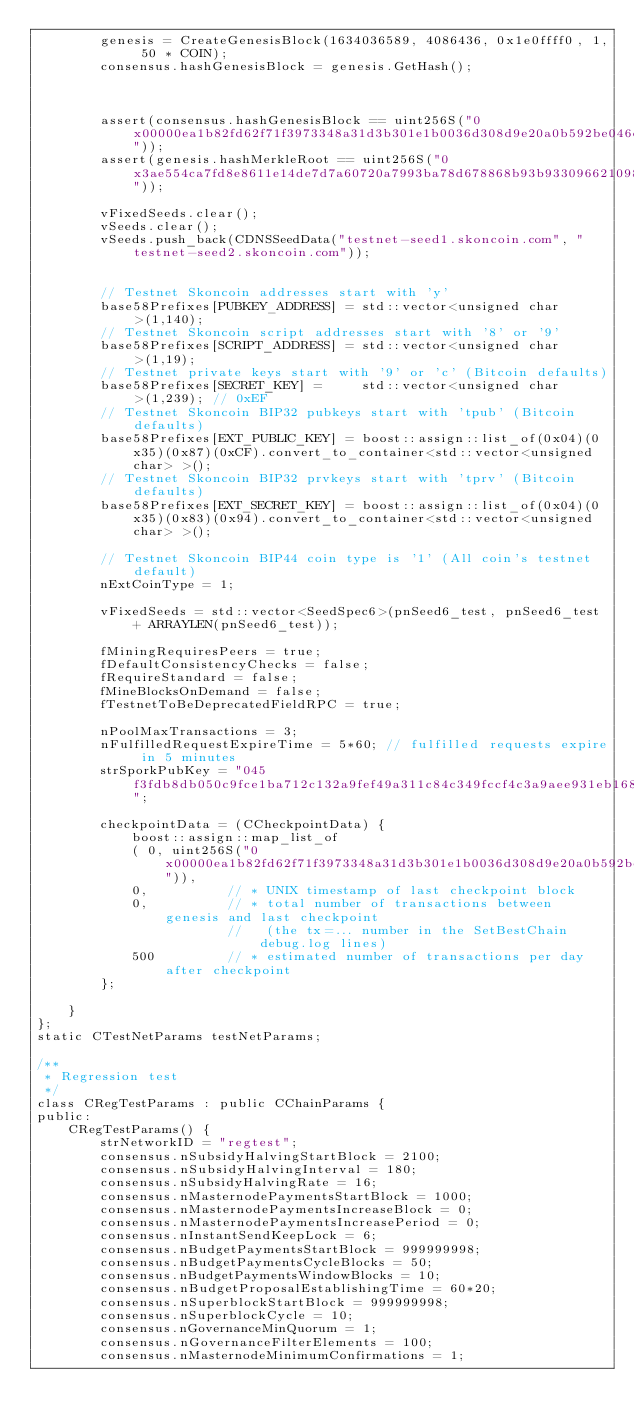<code> <loc_0><loc_0><loc_500><loc_500><_C++_>        genesis = CreateGenesisBlock(1634036589, 4086436, 0x1e0ffff0, 1, 50 * COIN);
        consensus.hashGenesisBlock = genesis.GetHash();

       

        assert(consensus.hashGenesisBlock == uint256S("0x00000ea1b82fd62f71f3973348a31d3b301e1b0036d308d9e20a0b592be046eb"));
        assert(genesis.hashMerkleRoot == uint256S("0x3ae554ca7fd8e8611e14de7d7a60720a7993ba78d678868b93b933096621098b"));

        vFixedSeeds.clear();
        vSeeds.clear();
        vSeeds.push_back(CDNSSeedData("testnet-seed1.skoncoin.com", "testnet-seed2.skoncoin.com"));


        // Testnet Skoncoin addresses start with 'y'
        base58Prefixes[PUBKEY_ADDRESS] = std::vector<unsigned char>(1,140);
        // Testnet Skoncoin script addresses start with '8' or '9'
        base58Prefixes[SCRIPT_ADDRESS] = std::vector<unsigned char>(1,19);
        // Testnet private keys start with '9' or 'c' (Bitcoin defaults)
        base58Prefixes[SECRET_KEY] =     std::vector<unsigned char>(1,239); // 0xEF
        // Testnet Skoncoin BIP32 pubkeys start with 'tpub' (Bitcoin defaults)
        base58Prefixes[EXT_PUBLIC_KEY] = boost::assign::list_of(0x04)(0x35)(0x87)(0xCF).convert_to_container<std::vector<unsigned char> >();
        // Testnet Skoncoin BIP32 prvkeys start with 'tprv' (Bitcoin defaults)
        base58Prefixes[EXT_SECRET_KEY] = boost::assign::list_of(0x04)(0x35)(0x83)(0x94).convert_to_container<std::vector<unsigned char> >();

        // Testnet Skoncoin BIP44 coin type is '1' (All coin's testnet default)
        nExtCoinType = 1;

        vFixedSeeds = std::vector<SeedSpec6>(pnSeed6_test, pnSeed6_test + ARRAYLEN(pnSeed6_test));

        fMiningRequiresPeers = true;
        fDefaultConsistencyChecks = false;
        fRequireStandard = false;
        fMineBlocksOnDemand = false;
        fTestnetToBeDeprecatedFieldRPC = true;

        nPoolMaxTransactions = 3;
        nFulfilledRequestExpireTime = 5*60; // fulfilled requests expire in 5 minutes
        strSporkPubKey = "045f3fdb8db050c9fce1ba712c132a9fef49a311c84c349fccf4c3a9aee931eb168c216aa54f6614318334cbdb409497ad0f87f1fab7c9c5dcd32f8d0dbf1369f4";

        checkpointData = (CCheckpointData) {
            boost::assign::map_list_of
            ( 0, uint256S("0x00000ea1b82fd62f71f3973348a31d3b301e1b0036d308d9e20a0b592be046eb")),
            0,          // * UNIX timestamp of last checkpoint block
            0,          // * total number of transactions between genesis and last checkpoint
                        //   (the tx=... number in the SetBestChain debug.log lines)
            500         // * estimated number of transactions per day after checkpoint
        };

    }
};
static CTestNetParams testNetParams;

/**
 * Regression test
 */
class CRegTestParams : public CChainParams {
public:
    CRegTestParams() {
        strNetworkID = "regtest";
        consensus.nSubsidyHalvingStartBlock = 2100;
        consensus.nSubsidyHalvingInterval = 180;
        consensus.nSubsidyHalvingRate = 16;
        consensus.nMasternodePaymentsStartBlock = 1000;
        consensus.nMasternodePaymentsIncreaseBlock = 0;
        consensus.nMasternodePaymentsIncreasePeriod = 0;
        consensus.nInstantSendKeepLock = 6;
        consensus.nBudgetPaymentsStartBlock = 999999998;
        consensus.nBudgetPaymentsCycleBlocks = 50;
        consensus.nBudgetPaymentsWindowBlocks = 10;
        consensus.nBudgetProposalEstablishingTime = 60*20;
        consensus.nSuperblockStartBlock = 999999998;
        consensus.nSuperblockCycle = 10;
        consensus.nGovernanceMinQuorum = 1;
        consensus.nGovernanceFilterElements = 100;
        consensus.nMasternodeMinimumConfirmations = 1;</code> 